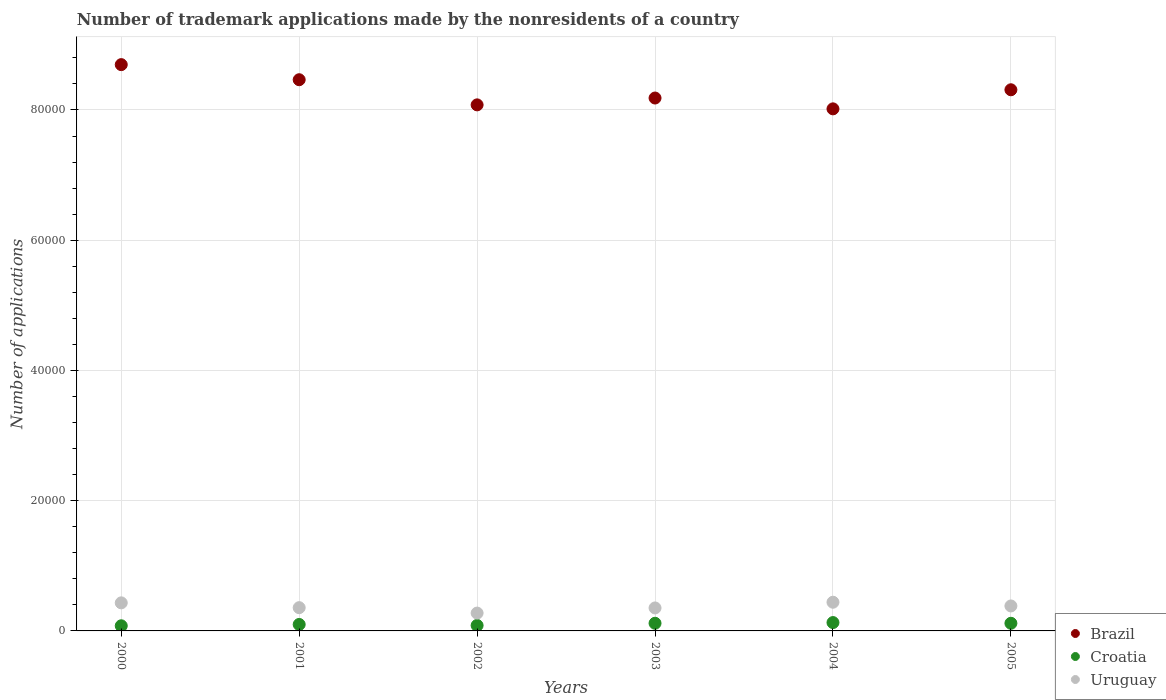Is the number of dotlines equal to the number of legend labels?
Provide a short and direct response. Yes. What is the number of trademark applications made by the nonresidents in Croatia in 2001?
Your answer should be very brief. 992. Across all years, what is the maximum number of trademark applications made by the nonresidents in Uruguay?
Your response must be concise. 4406. Across all years, what is the minimum number of trademark applications made by the nonresidents in Brazil?
Give a very brief answer. 8.02e+04. In which year was the number of trademark applications made by the nonresidents in Uruguay maximum?
Provide a short and direct response. 2004. In which year was the number of trademark applications made by the nonresidents in Brazil minimum?
Keep it short and to the point. 2004. What is the total number of trademark applications made by the nonresidents in Brazil in the graph?
Ensure brevity in your answer.  4.97e+05. What is the difference between the number of trademark applications made by the nonresidents in Uruguay in 2002 and that in 2005?
Your answer should be very brief. -1095. What is the difference between the number of trademark applications made by the nonresidents in Brazil in 2002 and the number of trademark applications made by the nonresidents in Croatia in 2001?
Provide a succinct answer. 7.98e+04. What is the average number of trademark applications made by the nonresidents in Croatia per year?
Your answer should be compact. 1042.5. In the year 2004, what is the difference between the number of trademark applications made by the nonresidents in Brazil and number of trademark applications made by the nonresidents in Uruguay?
Offer a terse response. 7.58e+04. What is the ratio of the number of trademark applications made by the nonresidents in Croatia in 2001 to that in 2002?
Keep it short and to the point. 1.18. Is the number of trademark applications made by the nonresidents in Croatia in 2001 less than that in 2004?
Provide a succinct answer. Yes. What is the difference between the highest and the second highest number of trademark applications made by the nonresidents in Croatia?
Your response must be concise. 107. What is the difference between the highest and the lowest number of trademark applications made by the nonresidents in Uruguay?
Your answer should be compact. 1667. In how many years, is the number of trademark applications made by the nonresidents in Brazil greater than the average number of trademark applications made by the nonresidents in Brazil taken over all years?
Provide a succinct answer. 3. Is the sum of the number of trademark applications made by the nonresidents in Croatia in 2000 and 2001 greater than the maximum number of trademark applications made by the nonresidents in Uruguay across all years?
Your answer should be compact. No. Is it the case that in every year, the sum of the number of trademark applications made by the nonresidents in Croatia and number of trademark applications made by the nonresidents in Brazil  is greater than the number of trademark applications made by the nonresidents in Uruguay?
Offer a very short reply. Yes. Does the number of trademark applications made by the nonresidents in Brazil monotonically increase over the years?
Keep it short and to the point. No. Is the number of trademark applications made by the nonresidents in Brazil strictly less than the number of trademark applications made by the nonresidents in Croatia over the years?
Give a very brief answer. No. How many dotlines are there?
Your answer should be very brief. 3. How many years are there in the graph?
Your answer should be very brief. 6. What is the difference between two consecutive major ticks on the Y-axis?
Your answer should be compact. 2.00e+04. Does the graph contain any zero values?
Provide a short and direct response. No. Does the graph contain grids?
Ensure brevity in your answer.  Yes. Where does the legend appear in the graph?
Offer a terse response. Bottom right. How many legend labels are there?
Your answer should be very brief. 3. What is the title of the graph?
Keep it short and to the point. Number of trademark applications made by the nonresidents of a country. Does "Egypt, Arab Rep." appear as one of the legend labels in the graph?
Your response must be concise. No. What is the label or title of the Y-axis?
Provide a succinct answer. Number of applications. What is the Number of applications in Brazil in 2000?
Provide a short and direct response. 8.70e+04. What is the Number of applications in Croatia in 2000?
Make the answer very short. 788. What is the Number of applications of Uruguay in 2000?
Provide a short and direct response. 4310. What is the Number of applications of Brazil in 2001?
Provide a succinct answer. 8.46e+04. What is the Number of applications in Croatia in 2001?
Provide a succinct answer. 992. What is the Number of applications of Uruguay in 2001?
Keep it short and to the point. 3571. What is the Number of applications in Brazil in 2002?
Offer a terse response. 8.08e+04. What is the Number of applications in Croatia in 2002?
Your response must be concise. 843. What is the Number of applications of Uruguay in 2002?
Your answer should be compact. 2739. What is the Number of applications in Brazil in 2003?
Provide a succinct answer. 8.18e+04. What is the Number of applications of Croatia in 2003?
Offer a very short reply. 1176. What is the Number of applications of Uruguay in 2003?
Provide a succinct answer. 3529. What is the Number of applications in Brazil in 2004?
Offer a terse response. 8.02e+04. What is the Number of applications in Croatia in 2004?
Ensure brevity in your answer.  1283. What is the Number of applications in Uruguay in 2004?
Ensure brevity in your answer.  4406. What is the Number of applications in Brazil in 2005?
Keep it short and to the point. 8.31e+04. What is the Number of applications in Croatia in 2005?
Provide a succinct answer. 1173. What is the Number of applications of Uruguay in 2005?
Your answer should be compact. 3834. Across all years, what is the maximum Number of applications in Brazil?
Ensure brevity in your answer.  8.70e+04. Across all years, what is the maximum Number of applications of Croatia?
Make the answer very short. 1283. Across all years, what is the maximum Number of applications of Uruguay?
Make the answer very short. 4406. Across all years, what is the minimum Number of applications in Brazil?
Give a very brief answer. 8.02e+04. Across all years, what is the minimum Number of applications of Croatia?
Offer a terse response. 788. Across all years, what is the minimum Number of applications in Uruguay?
Your answer should be very brief. 2739. What is the total Number of applications of Brazil in the graph?
Offer a very short reply. 4.97e+05. What is the total Number of applications in Croatia in the graph?
Make the answer very short. 6255. What is the total Number of applications of Uruguay in the graph?
Ensure brevity in your answer.  2.24e+04. What is the difference between the Number of applications of Brazil in 2000 and that in 2001?
Your answer should be very brief. 2317. What is the difference between the Number of applications of Croatia in 2000 and that in 2001?
Make the answer very short. -204. What is the difference between the Number of applications in Uruguay in 2000 and that in 2001?
Your answer should be very brief. 739. What is the difference between the Number of applications in Brazil in 2000 and that in 2002?
Your response must be concise. 6178. What is the difference between the Number of applications of Croatia in 2000 and that in 2002?
Give a very brief answer. -55. What is the difference between the Number of applications in Uruguay in 2000 and that in 2002?
Your response must be concise. 1571. What is the difference between the Number of applications in Brazil in 2000 and that in 2003?
Your response must be concise. 5128. What is the difference between the Number of applications in Croatia in 2000 and that in 2003?
Ensure brevity in your answer.  -388. What is the difference between the Number of applications of Uruguay in 2000 and that in 2003?
Keep it short and to the point. 781. What is the difference between the Number of applications of Brazil in 2000 and that in 2004?
Make the answer very short. 6791. What is the difference between the Number of applications in Croatia in 2000 and that in 2004?
Ensure brevity in your answer.  -495. What is the difference between the Number of applications of Uruguay in 2000 and that in 2004?
Your response must be concise. -96. What is the difference between the Number of applications of Brazil in 2000 and that in 2005?
Make the answer very short. 3861. What is the difference between the Number of applications of Croatia in 2000 and that in 2005?
Your answer should be compact. -385. What is the difference between the Number of applications of Uruguay in 2000 and that in 2005?
Your answer should be compact. 476. What is the difference between the Number of applications in Brazil in 2001 and that in 2002?
Offer a very short reply. 3861. What is the difference between the Number of applications of Croatia in 2001 and that in 2002?
Your answer should be very brief. 149. What is the difference between the Number of applications in Uruguay in 2001 and that in 2002?
Your answer should be very brief. 832. What is the difference between the Number of applications of Brazil in 2001 and that in 2003?
Provide a succinct answer. 2811. What is the difference between the Number of applications in Croatia in 2001 and that in 2003?
Make the answer very short. -184. What is the difference between the Number of applications in Brazil in 2001 and that in 2004?
Ensure brevity in your answer.  4474. What is the difference between the Number of applications of Croatia in 2001 and that in 2004?
Give a very brief answer. -291. What is the difference between the Number of applications in Uruguay in 2001 and that in 2004?
Make the answer very short. -835. What is the difference between the Number of applications in Brazil in 2001 and that in 2005?
Provide a succinct answer. 1544. What is the difference between the Number of applications of Croatia in 2001 and that in 2005?
Your response must be concise. -181. What is the difference between the Number of applications in Uruguay in 2001 and that in 2005?
Provide a short and direct response. -263. What is the difference between the Number of applications of Brazil in 2002 and that in 2003?
Your answer should be very brief. -1050. What is the difference between the Number of applications in Croatia in 2002 and that in 2003?
Provide a short and direct response. -333. What is the difference between the Number of applications of Uruguay in 2002 and that in 2003?
Provide a succinct answer. -790. What is the difference between the Number of applications in Brazil in 2002 and that in 2004?
Offer a terse response. 613. What is the difference between the Number of applications of Croatia in 2002 and that in 2004?
Your answer should be very brief. -440. What is the difference between the Number of applications of Uruguay in 2002 and that in 2004?
Make the answer very short. -1667. What is the difference between the Number of applications in Brazil in 2002 and that in 2005?
Provide a succinct answer. -2317. What is the difference between the Number of applications in Croatia in 2002 and that in 2005?
Keep it short and to the point. -330. What is the difference between the Number of applications in Uruguay in 2002 and that in 2005?
Your answer should be compact. -1095. What is the difference between the Number of applications of Brazil in 2003 and that in 2004?
Offer a terse response. 1663. What is the difference between the Number of applications in Croatia in 2003 and that in 2004?
Offer a terse response. -107. What is the difference between the Number of applications in Uruguay in 2003 and that in 2004?
Keep it short and to the point. -877. What is the difference between the Number of applications in Brazil in 2003 and that in 2005?
Provide a succinct answer. -1267. What is the difference between the Number of applications in Croatia in 2003 and that in 2005?
Ensure brevity in your answer.  3. What is the difference between the Number of applications of Uruguay in 2003 and that in 2005?
Keep it short and to the point. -305. What is the difference between the Number of applications in Brazil in 2004 and that in 2005?
Offer a terse response. -2930. What is the difference between the Number of applications of Croatia in 2004 and that in 2005?
Ensure brevity in your answer.  110. What is the difference between the Number of applications of Uruguay in 2004 and that in 2005?
Keep it short and to the point. 572. What is the difference between the Number of applications in Brazil in 2000 and the Number of applications in Croatia in 2001?
Offer a terse response. 8.60e+04. What is the difference between the Number of applications in Brazil in 2000 and the Number of applications in Uruguay in 2001?
Provide a succinct answer. 8.34e+04. What is the difference between the Number of applications in Croatia in 2000 and the Number of applications in Uruguay in 2001?
Make the answer very short. -2783. What is the difference between the Number of applications in Brazil in 2000 and the Number of applications in Croatia in 2002?
Provide a short and direct response. 8.61e+04. What is the difference between the Number of applications of Brazil in 2000 and the Number of applications of Uruguay in 2002?
Keep it short and to the point. 8.42e+04. What is the difference between the Number of applications in Croatia in 2000 and the Number of applications in Uruguay in 2002?
Keep it short and to the point. -1951. What is the difference between the Number of applications of Brazil in 2000 and the Number of applications of Croatia in 2003?
Provide a short and direct response. 8.58e+04. What is the difference between the Number of applications of Brazil in 2000 and the Number of applications of Uruguay in 2003?
Offer a very short reply. 8.34e+04. What is the difference between the Number of applications of Croatia in 2000 and the Number of applications of Uruguay in 2003?
Your answer should be very brief. -2741. What is the difference between the Number of applications in Brazil in 2000 and the Number of applications in Croatia in 2004?
Your response must be concise. 8.57e+04. What is the difference between the Number of applications of Brazil in 2000 and the Number of applications of Uruguay in 2004?
Make the answer very short. 8.26e+04. What is the difference between the Number of applications of Croatia in 2000 and the Number of applications of Uruguay in 2004?
Make the answer very short. -3618. What is the difference between the Number of applications in Brazil in 2000 and the Number of applications in Croatia in 2005?
Your answer should be compact. 8.58e+04. What is the difference between the Number of applications of Brazil in 2000 and the Number of applications of Uruguay in 2005?
Your response must be concise. 8.31e+04. What is the difference between the Number of applications in Croatia in 2000 and the Number of applications in Uruguay in 2005?
Your answer should be very brief. -3046. What is the difference between the Number of applications in Brazil in 2001 and the Number of applications in Croatia in 2002?
Offer a terse response. 8.38e+04. What is the difference between the Number of applications in Brazil in 2001 and the Number of applications in Uruguay in 2002?
Provide a succinct answer. 8.19e+04. What is the difference between the Number of applications of Croatia in 2001 and the Number of applications of Uruguay in 2002?
Provide a succinct answer. -1747. What is the difference between the Number of applications of Brazil in 2001 and the Number of applications of Croatia in 2003?
Your answer should be compact. 8.35e+04. What is the difference between the Number of applications in Brazil in 2001 and the Number of applications in Uruguay in 2003?
Offer a very short reply. 8.11e+04. What is the difference between the Number of applications in Croatia in 2001 and the Number of applications in Uruguay in 2003?
Provide a succinct answer. -2537. What is the difference between the Number of applications of Brazil in 2001 and the Number of applications of Croatia in 2004?
Offer a very short reply. 8.34e+04. What is the difference between the Number of applications in Brazil in 2001 and the Number of applications in Uruguay in 2004?
Your answer should be compact. 8.02e+04. What is the difference between the Number of applications in Croatia in 2001 and the Number of applications in Uruguay in 2004?
Ensure brevity in your answer.  -3414. What is the difference between the Number of applications of Brazil in 2001 and the Number of applications of Croatia in 2005?
Give a very brief answer. 8.35e+04. What is the difference between the Number of applications of Brazil in 2001 and the Number of applications of Uruguay in 2005?
Your answer should be compact. 8.08e+04. What is the difference between the Number of applications of Croatia in 2001 and the Number of applications of Uruguay in 2005?
Give a very brief answer. -2842. What is the difference between the Number of applications of Brazil in 2002 and the Number of applications of Croatia in 2003?
Your answer should be very brief. 7.96e+04. What is the difference between the Number of applications in Brazil in 2002 and the Number of applications in Uruguay in 2003?
Ensure brevity in your answer.  7.73e+04. What is the difference between the Number of applications in Croatia in 2002 and the Number of applications in Uruguay in 2003?
Give a very brief answer. -2686. What is the difference between the Number of applications of Brazil in 2002 and the Number of applications of Croatia in 2004?
Keep it short and to the point. 7.95e+04. What is the difference between the Number of applications of Brazil in 2002 and the Number of applications of Uruguay in 2004?
Provide a short and direct response. 7.64e+04. What is the difference between the Number of applications in Croatia in 2002 and the Number of applications in Uruguay in 2004?
Provide a succinct answer. -3563. What is the difference between the Number of applications in Brazil in 2002 and the Number of applications in Croatia in 2005?
Offer a terse response. 7.96e+04. What is the difference between the Number of applications of Brazil in 2002 and the Number of applications of Uruguay in 2005?
Ensure brevity in your answer.  7.69e+04. What is the difference between the Number of applications in Croatia in 2002 and the Number of applications in Uruguay in 2005?
Your answer should be compact. -2991. What is the difference between the Number of applications in Brazil in 2003 and the Number of applications in Croatia in 2004?
Provide a short and direct response. 8.05e+04. What is the difference between the Number of applications of Brazil in 2003 and the Number of applications of Uruguay in 2004?
Ensure brevity in your answer.  7.74e+04. What is the difference between the Number of applications of Croatia in 2003 and the Number of applications of Uruguay in 2004?
Your answer should be compact. -3230. What is the difference between the Number of applications in Brazil in 2003 and the Number of applications in Croatia in 2005?
Make the answer very short. 8.07e+04. What is the difference between the Number of applications of Brazil in 2003 and the Number of applications of Uruguay in 2005?
Keep it short and to the point. 7.80e+04. What is the difference between the Number of applications of Croatia in 2003 and the Number of applications of Uruguay in 2005?
Your response must be concise. -2658. What is the difference between the Number of applications of Brazil in 2004 and the Number of applications of Croatia in 2005?
Keep it short and to the point. 7.90e+04. What is the difference between the Number of applications of Brazil in 2004 and the Number of applications of Uruguay in 2005?
Your answer should be very brief. 7.63e+04. What is the difference between the Number of applications of Croatia in 2004 and the Number of applications of Uruguay in 2005?
Provide a succinct answer. -2551. What is the average Number of applications of Brazil per year?
Give a very brief answer. 8.29e+04. What is the average Number of applications in Croatia per year?
Your response must be concise. 1042.5. What is the average Number of applications in Uruguay per year?
Make the answer very short. 3731.5. In the year 2000, what is the difference between the Number of applications of Brazil and Number of applications of Croatia?
Offer a terse response. 8.62e+04. In the year 2000, what is the difference between the Number of applications in Brazil and Number of applications in Uruguay?
Make the answer very short. 8.26e+04. In the year 2000, what is the difference between the Number of applications in Croatia and Number of applications in Uruguay?
Provide a short and direct response. -3522. In the year 2001, what is the difference between the Number of applications in Brazil and Number of applications in Croatia?
Keep it short and to the point. 8.37e+04. In the year 2001, what is the difference between the Number of applications of Brazil and Number of applications of Uruguay?
Keep it short and to the point. 8.11e+04. In the year 2001, what is the difference between the Number of applications of Croatia and Number of applications of Uruguay?
Make the answer very short. -2579. In the year 2002, what is the difference between the Number of applications in Brazil and Number of applications in Croatia?
Offer a terse response. 7.99e+04. In the year 2002, what is the difference between the Number of applications in Brazil and Number of applications in Uruguay?
Ensure brevity in your answer.  7.80e+04. In the year 2002, what is the difference between the Number of applications of Croatia and Number of applications of Uruguay?
Your response must be concise. -1896. In the year 2003, what is the difference between the Number of applications in Brazil and Number of applications in Croatia?
Make the answer very short. 8.07e+04. In the year 2003, what is the difference between the Number of applications of Brazil and Number of applications of Uruguay?
Provide a short and direct response. 7.83e+04. In the year 2003, what is the difference between the Number of applications of Croatia and Number of applications of Uruguay?
Give a very brief answer. -2353. In the year 2004, what is the difference between the Number of applications in Brazil and Number of applications in Croatia?
Make the answer very short. 7.89e+04. In the year 2004, what is the difference between the Number of applications in Brazil and Number of applications in Uruguay?
Offer a terse response. 7.58e+04. In the year 2004, what is the difference between the Number of applications in Croatia and Number of applications in Uruguay?
Offer a terse response. -3123. In the year 2005, what is the difference between the Number of applications of Brazil and Number of applications of Croatia?
Provide a short and direct response. 8.19e+04. In the year 2005, what is the difference between the Number of applications of Brazil and Number of applications of Uruguay?
Offer a terse response. 7.93e+04. In the year 2005, what is the difference between the Number of applications in Croatia and Number of applications in Uruguay?
Provide a short and direct response. -2661. What is the ratio of the Number of applications in Brazil in 2000 to that in 2001?
Your response must be concise. 1.03. What is the ratio of the Number of applications in Croatia in 2000 to that in 2001?
Give a very brief answer. 0.79. What is the ratio of the Number of applications in Uruguay in 2000 to that in 2001?
Ensure brevity in your answer.  1.21. What is the ratio of the Number of applications in Brazil in 2000 to that in 2002?
Keep it short and to the point. 1.08. What is the ratio of the Number of applications in Croatia in 2000 to that in 2002?
Your answer should be compact. 0.93. What is the ratio of the Number of applications of Uruguay in 2000 to that in 2002?
Make the answer very short. 1.57. What is the ratio of the Number of applications of Brazil in 2000 to that in 2003?
Make the answer very short. 1.06. What is the ratio of the Number of applications of Croatia in 2000 to that in 2003?
Your response must be concise. 0.67. What is the ratio of the Number of applications of Uruguay in 2000 to that in 2003?
Ensure brevity in your answer.  1.22. What is the ratio of the Number of applications of Brazil in 2000 to that in 2004?
Your answer should be compact. 1.08. What is the ratio of the Number of applications of Croatia in 2000 to that in 2004?
Provide a short and direct response. 0.61. What is the ratio of the Number of applications in Uruguay in 2000 to that in 2004?
Keep it short and to the point. 0.98. What is the ratio of the Number of applications of Brazil in 2000 to that in 2005?
Ensure brevity in your answer.  1.05. What is the ratio of the Number of applications of Croatia in 2000 to that in 2005?
Your answer should be very brief. 0.67. What is the ratio of the Number of applications in Uruguay in 2000 to that in 2005?
Offer a very short reply. 1.12. What is the ratio of the Number of applications in Brazil in 2001 to that in 2002?
Your response must be concise. 1.05. What is the ratio of the Number of applications in Croatia in 2001 to that in 2002?
Ensure brevity in your answer.  1.18. What is the ratio of the Number of applications of Uruguay in 2001 to that in 2002?
Make the answer very short. 1.3. What is the ratio of the Number of applications of Brazil in 2001 to that in 2003?
Ensure brevity in your answer.  1.03. What is the ratio of the Number of applications of Croatia in 2001 to that in 2003?
Make the answer very short. 0.84. What is the ratio of the Number of applications of Uruguay in 2001 to that in 2003?
Your answer should be compact. 1.01. What is the ratio of the Number of applications in Brazil in 2001 to that in 2004?
Ensure brevity in your answer.  1.06. What is the ratio of the Number of applications of Croatia in 2001 to that in 2004?
Make the answer very short. 0.77. What is the ratio of the Number of applications in Uruguay in 2001 to that in 2004?
Keep it short and to the point. 0.81. What is the ratio of the Number of applications in Brazil in 2001 to that in 2005?
Give a very brief answer. 1.02. What is the ratio of the Number of applications of Croatia in 2001 to that in 2005?
Your answer should be compact. 0.85. What is the ratio of the Number of applications of Uruguay in 2001 to that in 2005?
Keep it short and to the point. 0.93. What is the ratio of the Number of applications of Brazil in 2002 to that in 2003?
Ensure brevity in your answer.  0.99. What is the ratio of the Number of applications in Croatia in 2002 to that in 2003?
Your response must be concise. 0.72. What is the ratio of the Number of applications of Uruguay in 2002 to that in 2003?
Keep it short and to the point. 0.78. What is the ratio of the Number of applications of Brazil in 2002 to that in 2004?
Make the answer very short. 1.01. What is the ratio of the Number of applications of Croatia in 2002 to that in 2004?
Your response must be concise. 0.66. What is the ratio of the Number of applications of Uruguay in 2002 to that in 2004?
Your response must be concise. 0.62. What is the ratio of the Number of applications of Brazil in 2002 to that in 2005?
Your answer should be very brief. 0.97. What is the ratio of the Number of applications in Croatia in 2002 to that in 2005?
Make the answer very short. 0.72. What is the ratio of the Number of applications of Uruguay in 2002 to that in 2005?
Your response must be concise. 0.71. What is the ratio of the Number of applications in Brazil in 2003 to that in 2004?
Provide a succinct answer. 1.02. What is the ratio of the Number of applications of Croatia in 2003 to that in 2004?
Your answer should be compact. 0.92. What is the ratio of the Number of applications in Uruguay in 2003 to that in 2004?
Keep it short and to the point. 0.8. What is the ratio of the Number of applications of Uruguay in 2003 to that in 2005?
Provide a succinct answer. 0.92. What is the ratio of the Number of applications of Brazil in 2004 to that in 2005?
Offer a very short reply. 0.96. What is the ratio of the Number of applications of Croatia in 2004 to that in 2005?
Provide a short and direct response. 1.09. What is the ratio of the Number of applications in Uruguay in 2004 to that in 2005?
Offer a very short reply. 1.15. What is the difference between the highest and the second highest Number of applications in Brazil?
Offer a very short reply. 2317. What is the difference between the highest and the second highest Number of applications of Croatia?
Your answer should be compact. 107. What is the difference between the highest and the second highest Number of applications of Uruguay?
Keep it short and to the point. 96. What is the difference between the highest and the lowest Number of applications in Brazil?
Offer a terse response. 6791. What is the difference between the highest and the lowest Number of applications of Croatia?
Your response must be concise. 495. What is the difference between the highest and the lowest Number of applications of Uruguay?
Offer a very short reply. 1667. 